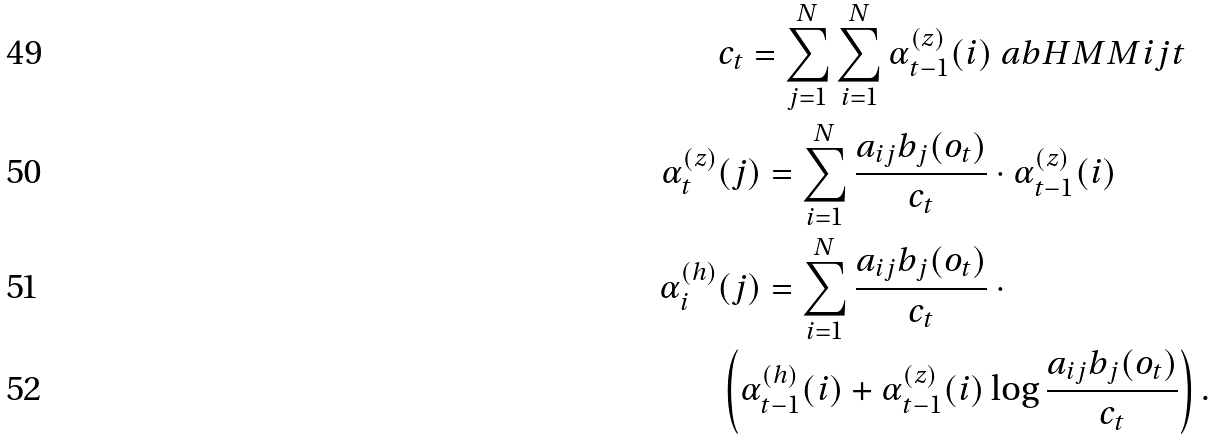<formula> <loc_0><loc_0><loc_500><loc_500>& c _ { t } = \sum _ { j = 1 } ^ { N } \sum _ { i = 1 } ^ { N } \alpha _ { t - 1 } ^ { ( z ) } ( i ) \ a b H M M { i } { j } { t } \\ \alpha _ { t } ^ { ( z ) } & ( j ) = \sum _ { i = 1 } ^ { N } \frac { a _ { i j } b _ { j } ( o _ { t } ) } { c _ { t } } \cdot \alpha _ { t - 1 } ^ { ( z ) } ( i ) \\ \alpha _ { i } ^ { ( h ) } & ( j ) = \sum _ { i = 1 } ^ { N } \frac { a _ { i j } b _ { j } ( o _ { t } ) } { c _ { t } } \ \cdot \\ & \left ( \alpha _ { t - 1 } ^ { ( h ) } ( i ) + \alpha _ { t - 1 } ^ { ( z ) } ( i ) \log \frac { a _ { i j } b _ { j } ( o _ { t } ) } { c _ { t } } \right ) .</formula> 